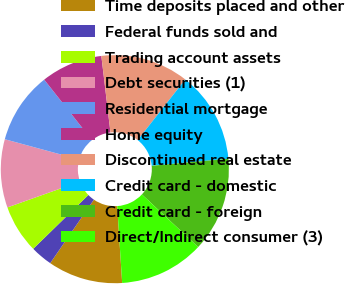Convert chart. <chart><loc_0><loc_0><loc_500><loc_500><pie_chart><fcel>Time deposits placed and other<fcel>Federal funds sold and<fcel>Trading account assets<fcel>Debt securities (1)<fcel>Residential mortgage<fcel>Home equity<fcel>Discontinued real estate<fcel>Credit card - domestic<fcel>Credit card - foreign<fcel>Direct/Indirect consumer (3)<nl><fcel>10.61%<fcel>3.11%<fcel>6.86%<fcel>9.67%<fcel>10.14%<fcel>8.74%<fcel>12.48%<fcel>12.95%<fcel>13.42%<fcel>12.01%<nl></chart> 